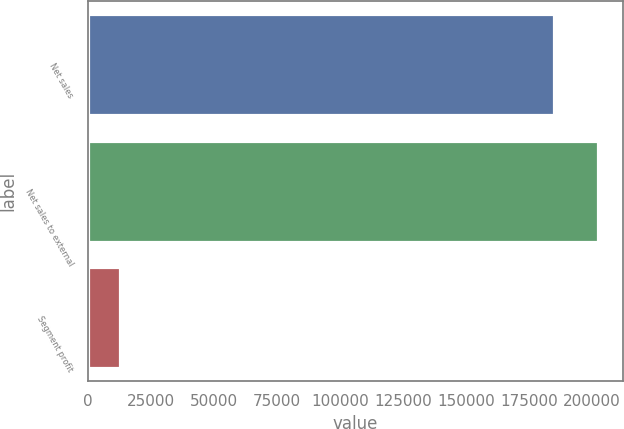Convert chart to OTSL. <chart><loc_0><loc_0><loc_500><loc_500><bar_chart><fcel>Net sales<fcel>Net sales to external<fcel>Segment profit<nl><fcel>185022<fcel>202266<fcel>12882<nl></chart> 